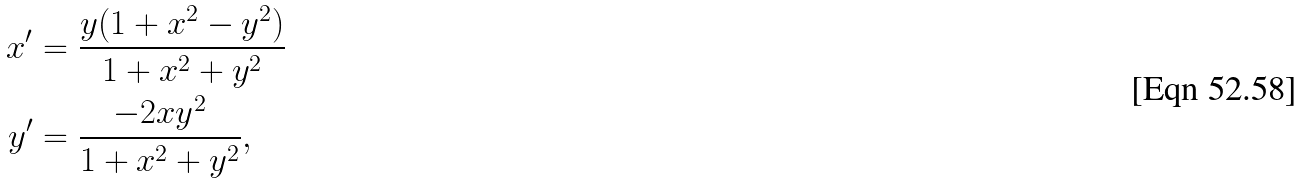<formula> <loc_0><loc_0><loc_500><loc_500>x ^ { \prime } & = \frac { y ( 1 + x ^ { 2 } - y ^ { 2 } ) } { 1 + x ^ { 2 } + y ^ { 2 } } \\ y ^ { \prime } & = \frac { - 2 x y ^ { 2 } } { 1 + x ^ { 2 } + y ^ { 2 } } ,</formula> 